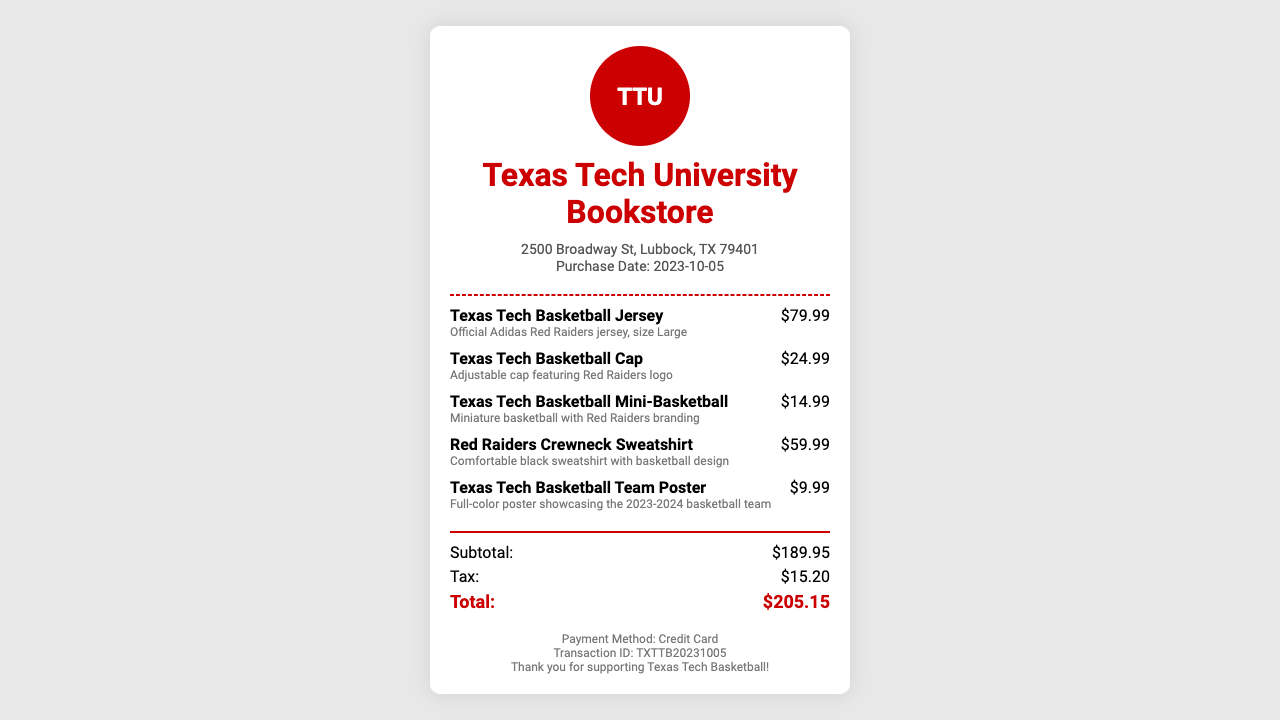What date was the purchase made? The purchase date is explicitly mentioned in the document under the store information section.
Answer: 2023-10-05 What is the price of the Texas Tech Basketball Cap? The price is listed next to the item name in the items section.
Answer: $24.99 What is the total after tax? The total amount is calculated by summing the subtotal and tax, which is noted at the bottom of the totals section.
Answer: $205.15 How much was paid for the Red Raiders Crewneck Sweatshirt? The specific price for each item is detailed beside their descriptions.
Answer: $59.99 What payment method was used? The payment method is stated in the footer of the receipt.
Answer: Credit Card What is the subtotal for the items purchased? The subtotal is specifically mentioned in the totals section of the receipt.
Answer: $189.95 What type of item is the Texas Tech Basketball Mini-Basketball? This is described in the item details, indicating it is a specific type of sports memorabilia.
Answer: Miniature basketball Which tax amount was applied to the purchase? The tax amount is detailed in the totals section.
Answer: $15.20 